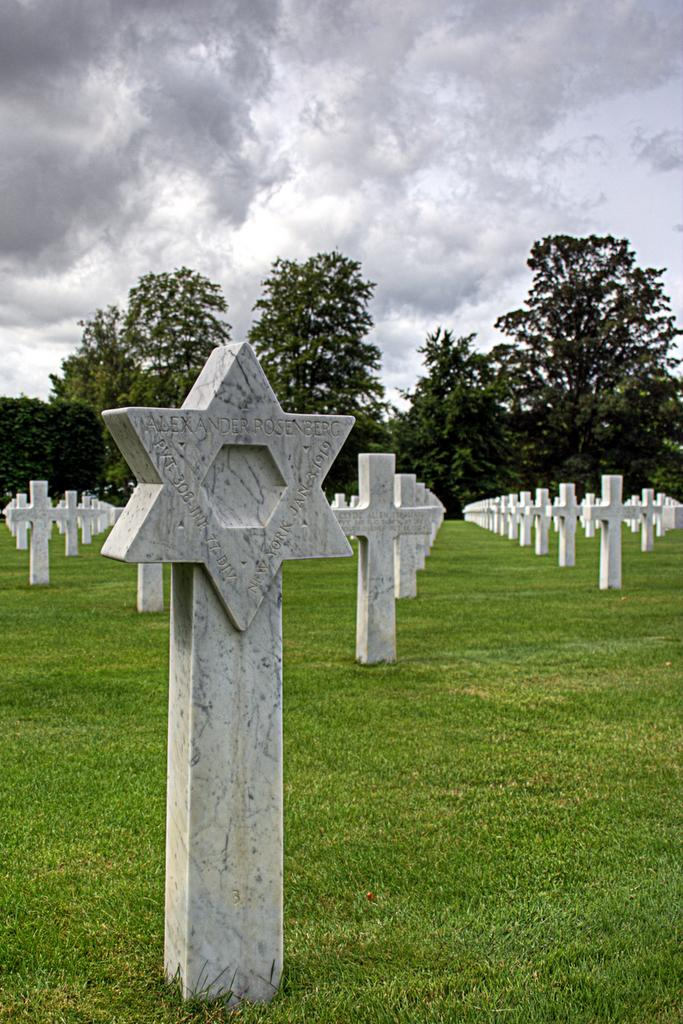What type of terrain is visible in the image? There is an open grass ground in the image. What can be seen on the grass ground? There are multiple white objects on the grass ground. What is visible in the background of the image? There are trees and clouds visible in the background. What part of the sky is visible in the image? The sky is visible in the background. What type of canvas is being used to paint the moon in the image? There is no canvas or painting of the moon present in the image. What experience can be gained from observing the image? The image itself does not convey any specific experience; it is a visual representation of an open grass ground with white objects, trees, clouds, and the sky. 